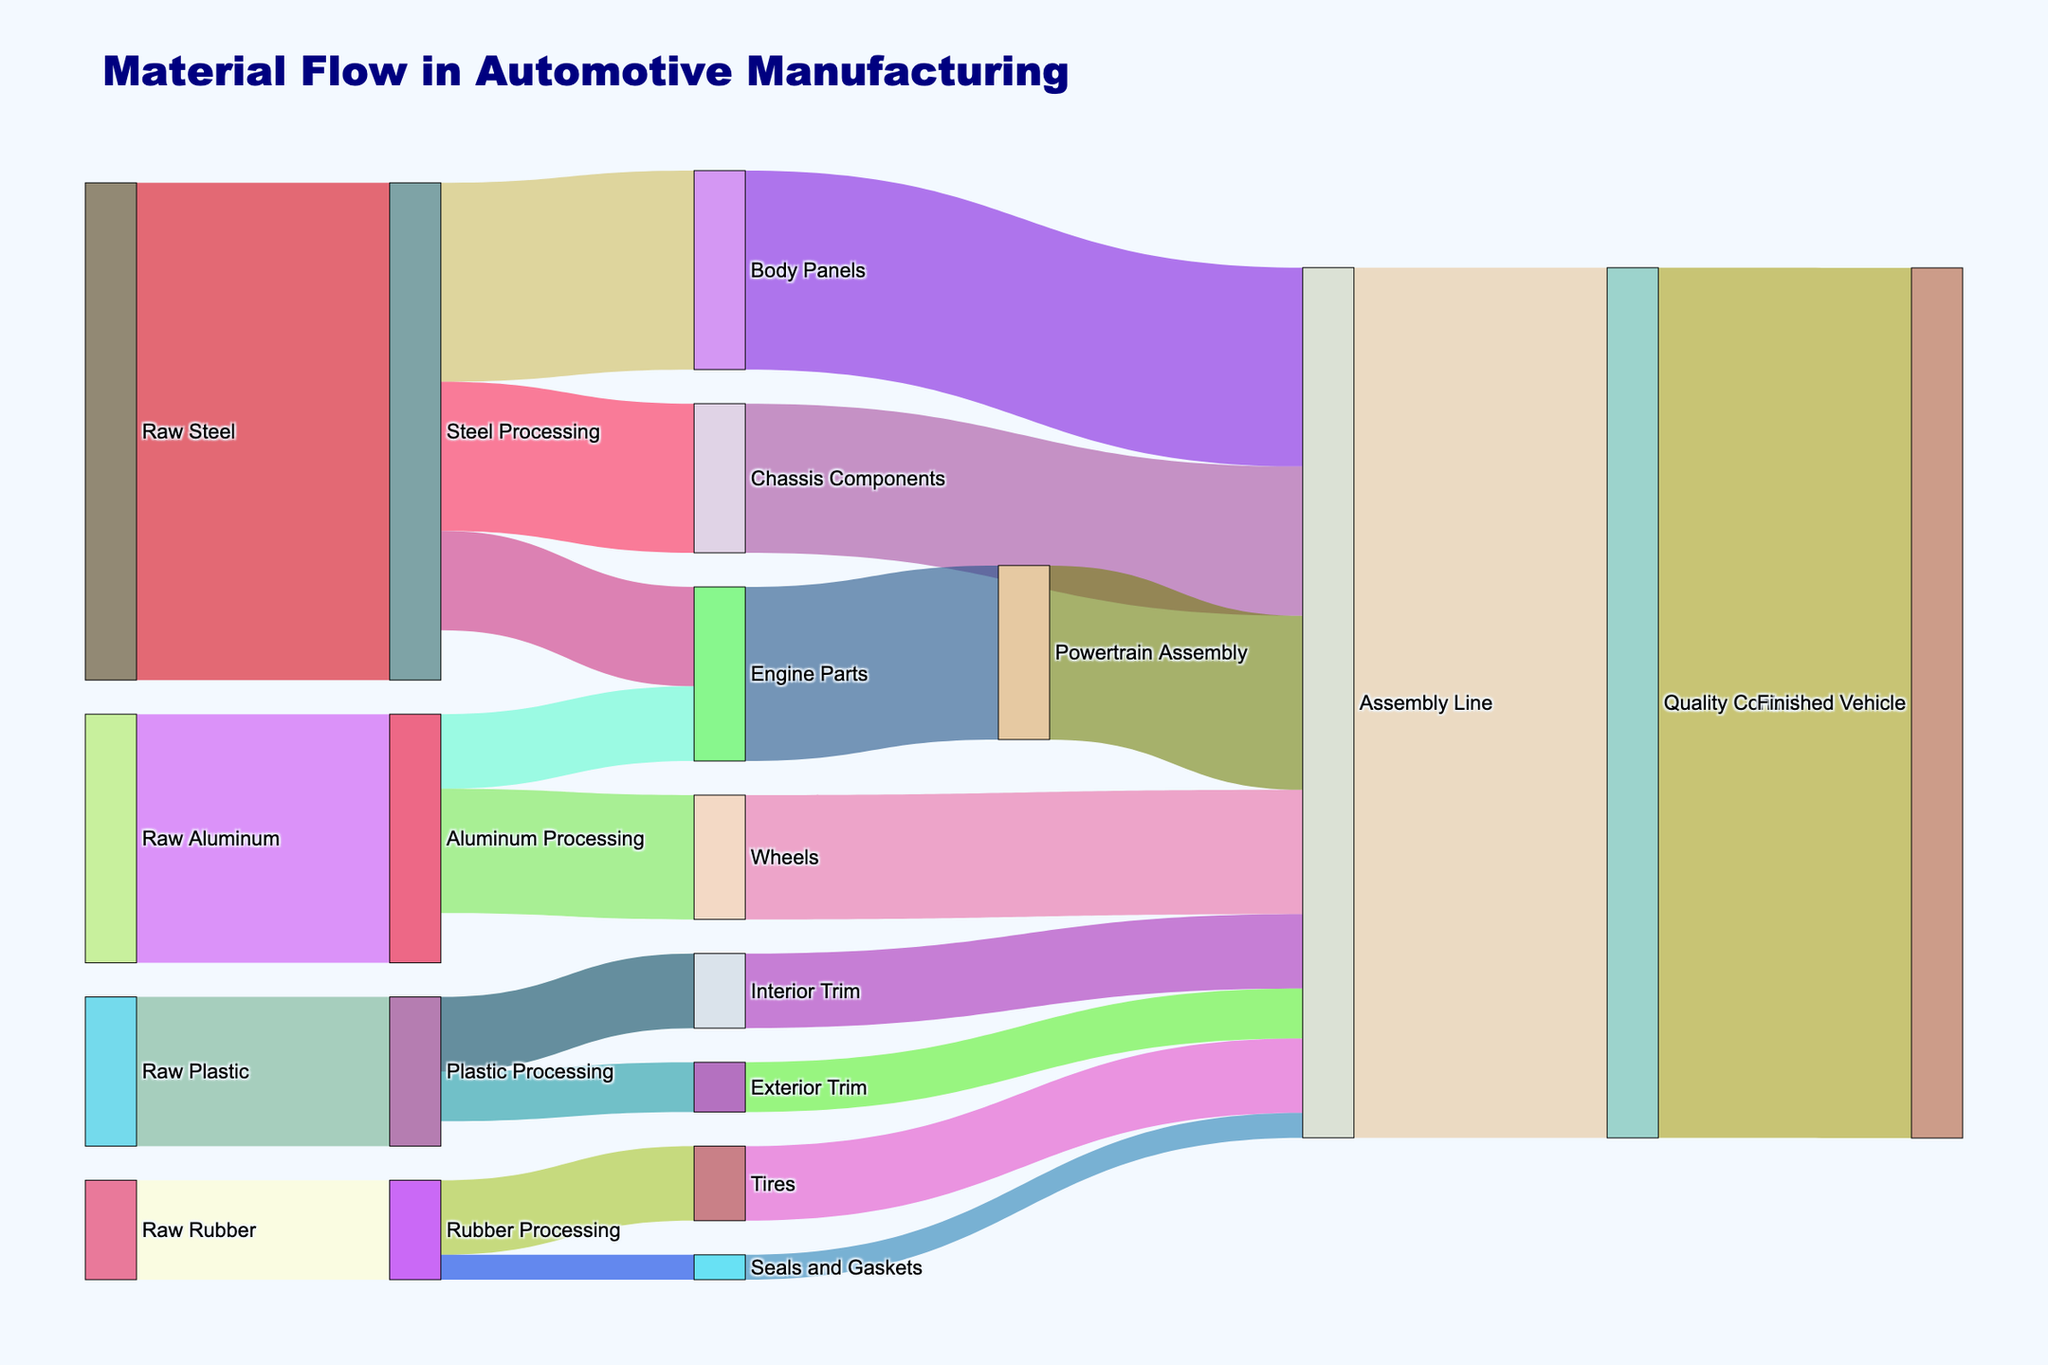What is the title of the Sankey diagram? The title is usually positioned at the top of the diagram and serves to provide an overview of the subject being visualized. In this case, the title is given in the plot code.
Answer: Material Flow in Automotive Manufacturing How many nodes are there in the Sankey diagram? To determine the number of nodes, count the unique entries in both the 'source' and 'target' columns of the data provided. These distinct elements represent the nodes in the diagram.
Answer: 17 How much raw steel is processed according to the Sankey diagram? To find this information, look for the value associated with the 'Raw Steel' node moving to 'Steel Processing.' This value represents the amount of raw steel processed.
Answer: 1000 How many types of processed materials are involved in the Sankey diagram? To find the types of processed materials, identify the entries in the 'target' column that follow 'Raw' materials in the 'source' column. Count the unique values like 'Steel Processing,' 'Aluminum Processing,' etc.
Answer: 4 Which component has the largest flow from the 'Assembly Line'? Look at the 'target' column entries where 'Assembly Line' is the 'source' and identify the component with the largest value.
Answer: Quality Control How much raw material in total is being processed? Add the values associated with each 'Raw' material node moving to their respective processing stages. The values to sum are 1000 (steel) + 500 (aluminum) + 200 (rubber) + 300 (plastic).
Answer: 2000 Which processed material flows into the most different target components? Examine the 'source' column for each processing stage (like 'Steel Processing') and count how many times each appears in the data to different 'target' components.
Answer: Steel Processing Compare the flow of 'Engine Parts' from 'Steel Processing' and 'Aluminum Processing.' Which is greater? Identify the values in the data where 'Engine Parts' is the 'target' for both 'Steel Processing' and 'Aluminum Processing,' and compare their magnitudes.
Answer: Steel Processing What is the total flow into the 'Assembly Line'? Add the values of all the flows where 'Assembly Line' is the 'target,' including from Body Panels, Chassis Components, Engine Parts, Wheels, Tires, etc.
Answer: 1750 What is the final output flow in the Sankey diagram? Track the flow through the diagram to the final 'target' which is 'Finished Vehicle,' and note its associated value.
Answer: 1750 